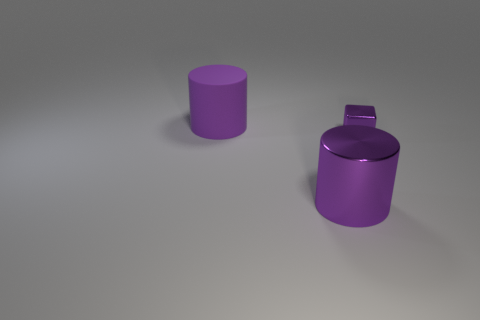Do the tiny thing and the large matte thing have the same color?
Provide a short and direct response. Yes. Is the big purple metallic thing the same shape as the big purple rubber thing?
Provide a short and direct response. Yes. There is a big purple thing left of the large purple metal thing to the left of the tiny purple shiny object; is there a tiny shiny cube that is in front of it?
Provide a short and direct response. Yes. How many metallic things are the same color as the big rubber cylinder?
Give a very brief answer. 2. There is a shiny object that is the same size as the rubber cylinder; what is its shape?
Provide a succinct answer. Cylinder. Are there any matte objects left of the metal block?
Keep it short and to the point. Yes. Do the matte object and the shiny cylinder have the same size?
Make the answer very short. Yes. The large purple object that is in front of the purple matte cylinder has what shape?
Provide a succinct answer. Cylinder. Is there a rubber cylinder of the same size as the metallic cylinder?
Offer a very short reply. Yes. There is another cylinder that is the same size as the purple matte cylinder; what material is it?
Ensure brevity in your answer.  Metal. 